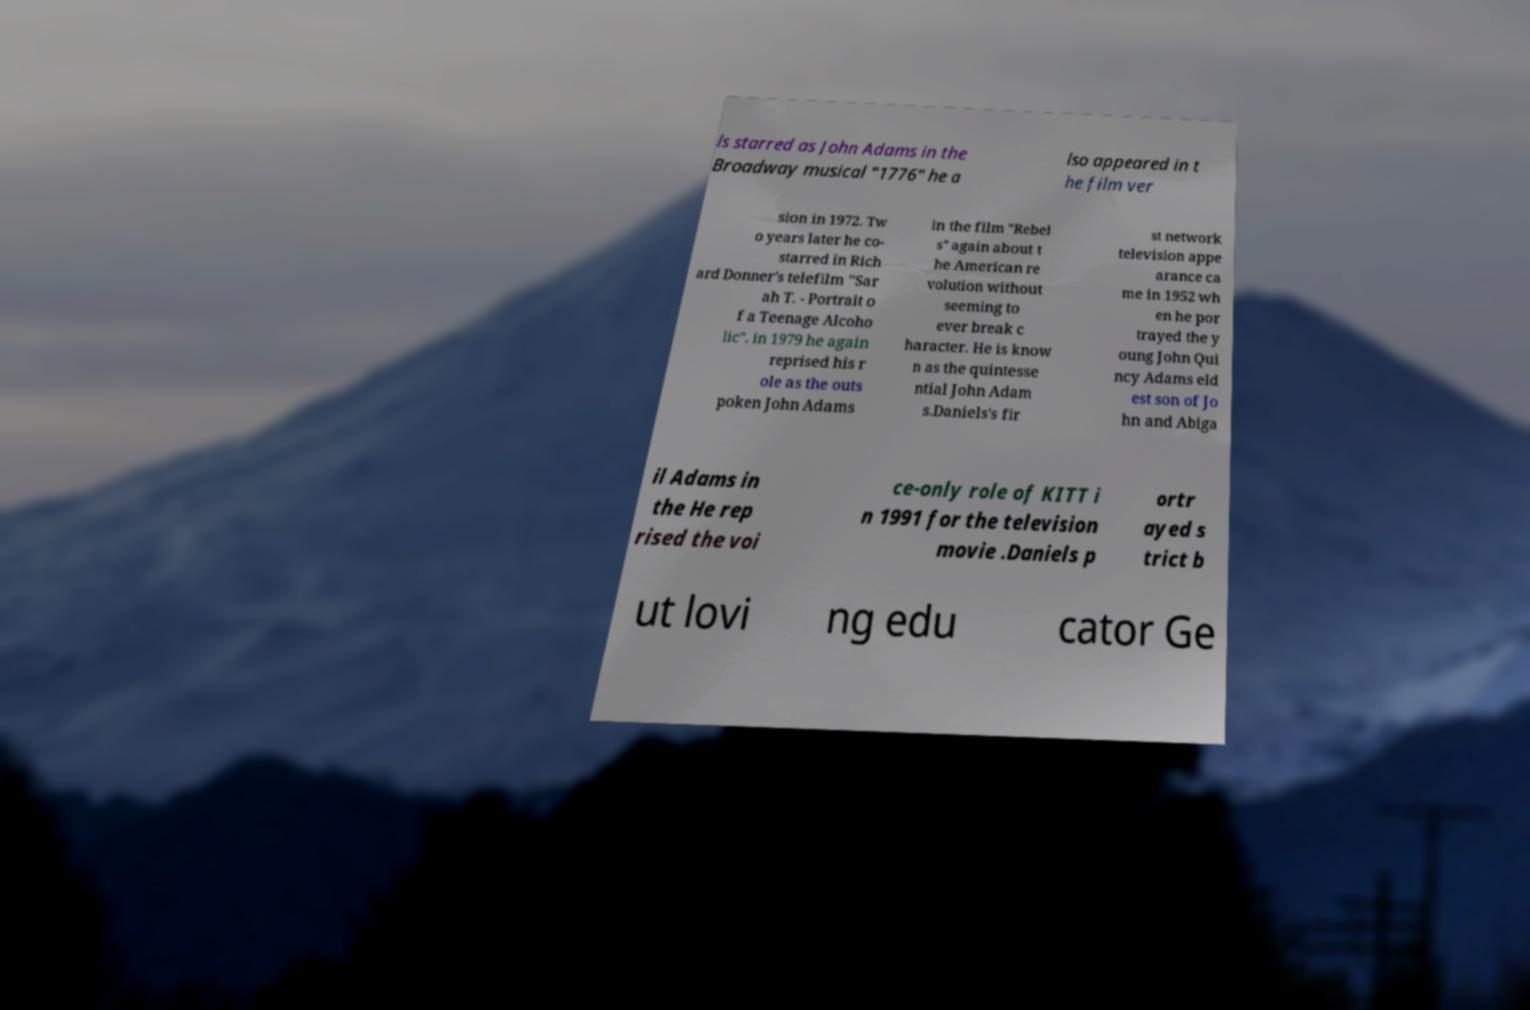There's text embedded in this image that I need extracted. Can you transcribe it verbatim? ls starred as John Adams in the Broadway musical "1776" he a lso appeared in t he film ver sion in 1972. Tw o years later he co- starred in Rich ard Donner's telefilm "Sar ah T. - Portrait o f a Teenage Alcoho lic". in 1979 he again reprised his r ole as the outs poken John Adams in the film "Rebel s" again about t he American re volution without seeming to ever break c haracter. He is know n as the quintesse ntial John Adam s.Daniels's fir st network television appe arance ca me in 1952 wh en he por trayed the y oung John Qui ncy Adams eld est son of Jo hn and Abiga il Adams in the He rep rised the voi ce-only role of KITT i n 1991 for the television movie .Daniels p ortr ayed s trict b ut lovi ng edu cator Ge 